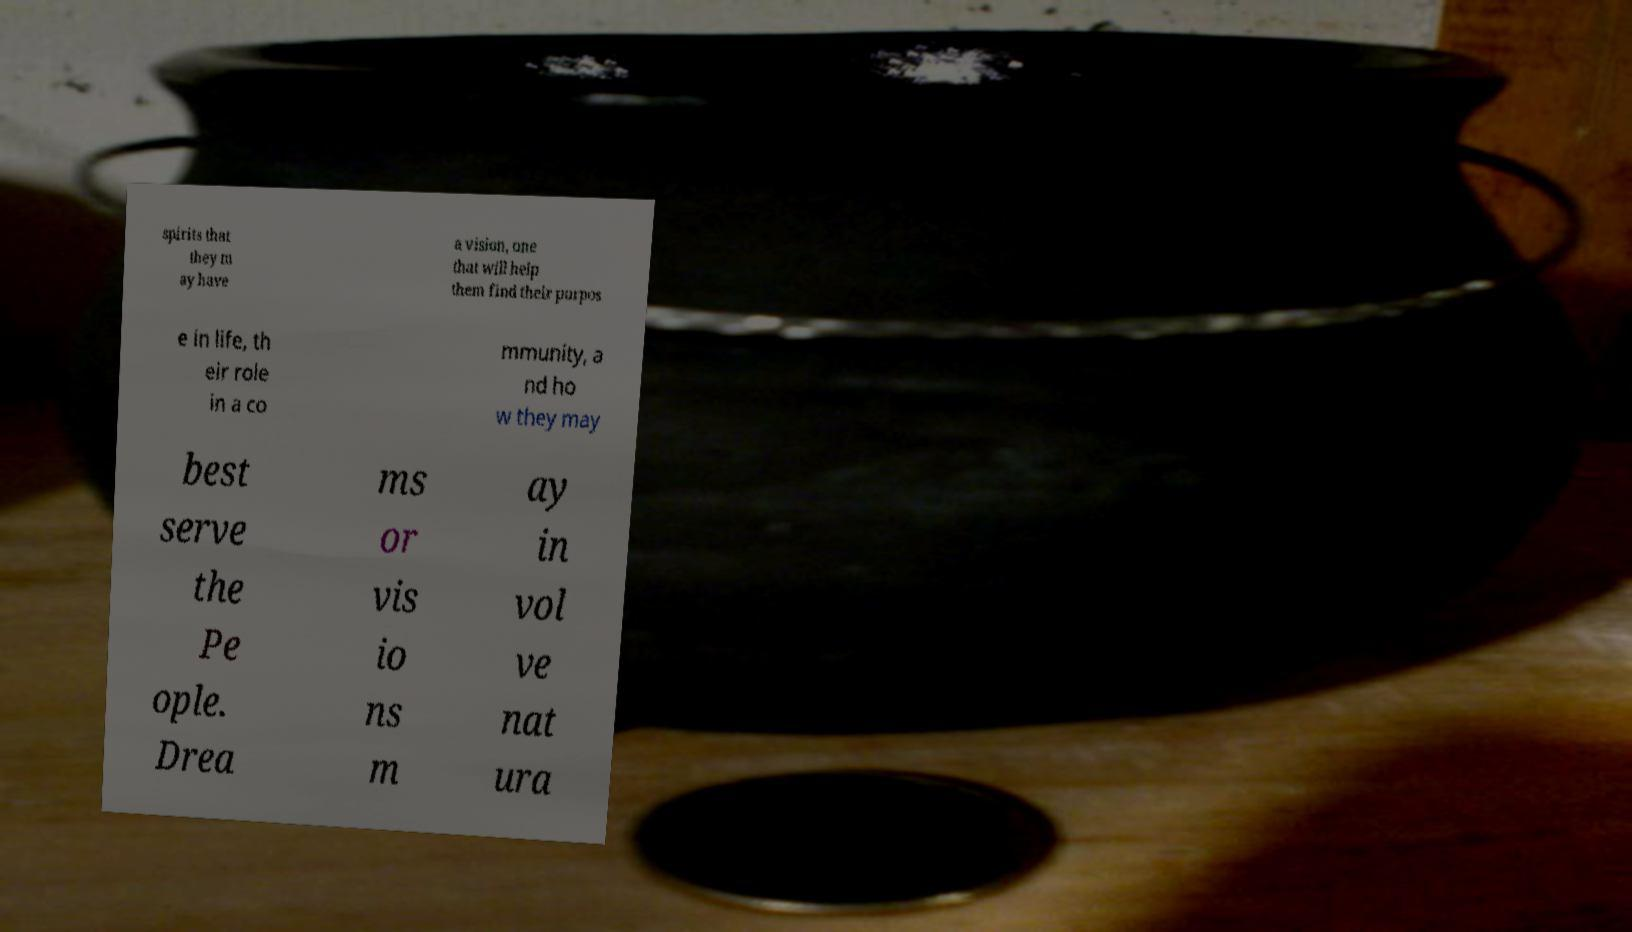Could you assist in decoding the text presented in this image and type it out clearly? spirits that they m ay have a vision, one that will help them find their purpos e in life, th eir role in a co mmunity, a nd ho w they may best serve the Pe ople. Drea ms or vis io ns m ay in vol ve nat ura 